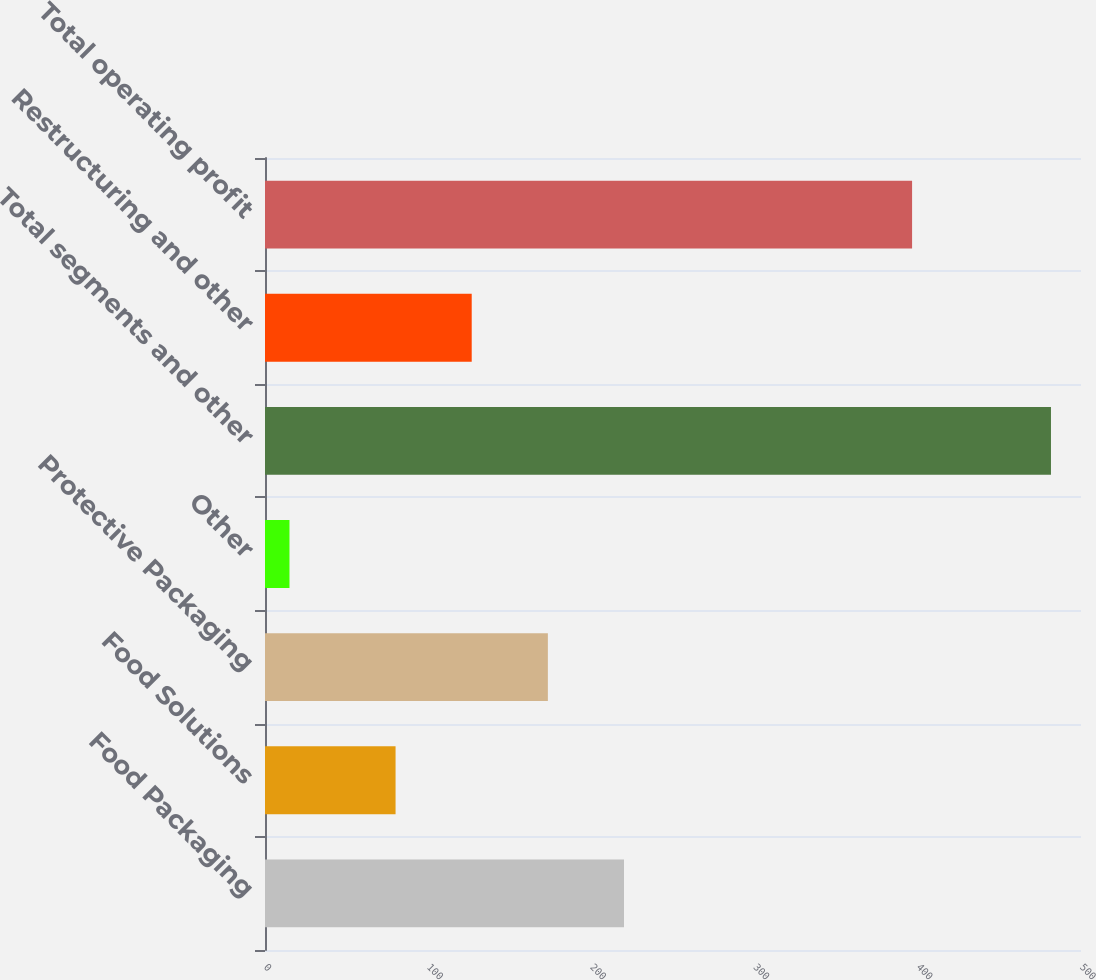<chart> <loc_0><loc_0><loc_500><loc_500><bar_chart><fcel>Food Packaging<fcel>Food Solutions<fcel>Protective Packaging<fcel>Other<fcel>Total segments and other<fcel>Restructuring and other<fcel>Total operating profit<nl><fcel>219.98<fcel>80<fcel>173.32<fcel>15<fcel>481.6<fcel>126.66<fcel>396.5<nl></chart> 